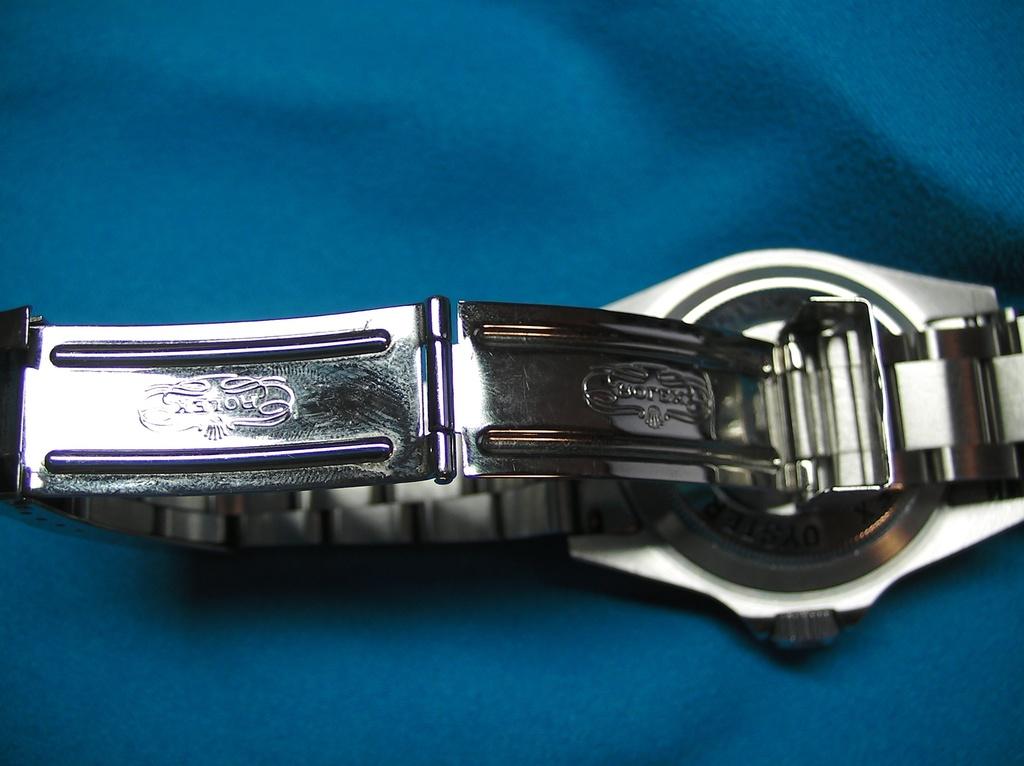What is the brand of the watch?
Make the answer very short. Rolex. 